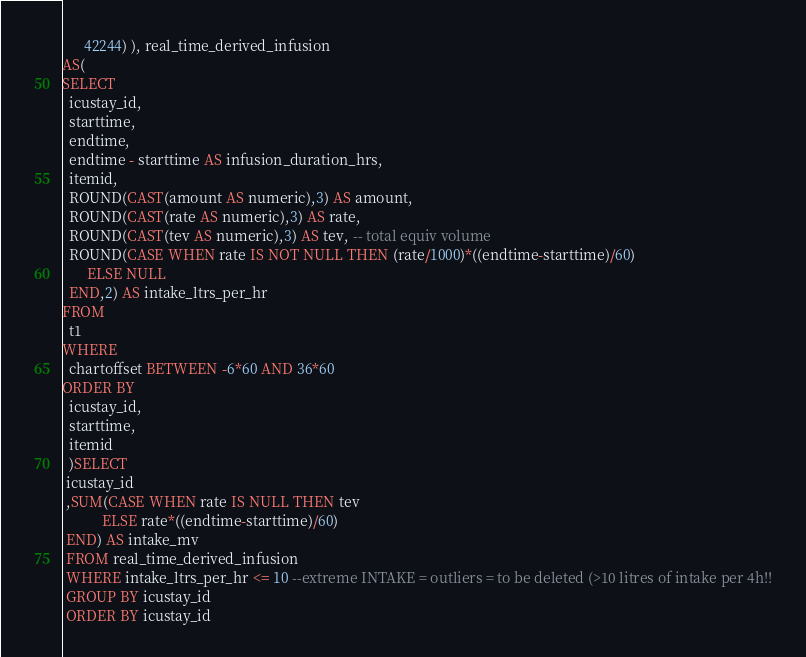<code> <loc_0><loc_0><loc_500><loc_500><_SQL_>      42244) ), real_time_derived_infusion
AS(      
SELECT
  icustay_id,
  starttime,
  endtime,
  endtime - starttime AS infusion_duration_hrs,
  itemid,
  ROUND(CAST(amount AS numeric),3) AS amount,
  ROUND(CAST(rate AS numeric),3) AS rate,
  ROUND(CAST(tev AS numeric),3) AS tev, -- total equiv volume
  ROUND(CASE WHEN rate IS NOT NULL THEN (rate/1000)*((endtime-starttime)/60) 
       ELSE NULL
  END,2) AS intake_ltrs_per_hr
FROM
  t1
WHERE
  chartoffset BETWEEN -6*60 AND 36*60
ORDER BY
  icustay_id,
  starttime,
  itemid
  )SELECT
 icustay_id 
 ,SUM(CASE WHEN rate IS NULL THEN tev
           ELSE rate*((endtime-starttime)/60) 
 END) AS intake_mv
 FROM real_time_derived_infusion
 WHERE intake_ltrs_per_hr <= 10 --extreme INTAKE = outliers = to be deleted (>10 litres of intake per 4h!!
 GROUP BY icustay_id
 ORDER BY icustay_id
</code> 